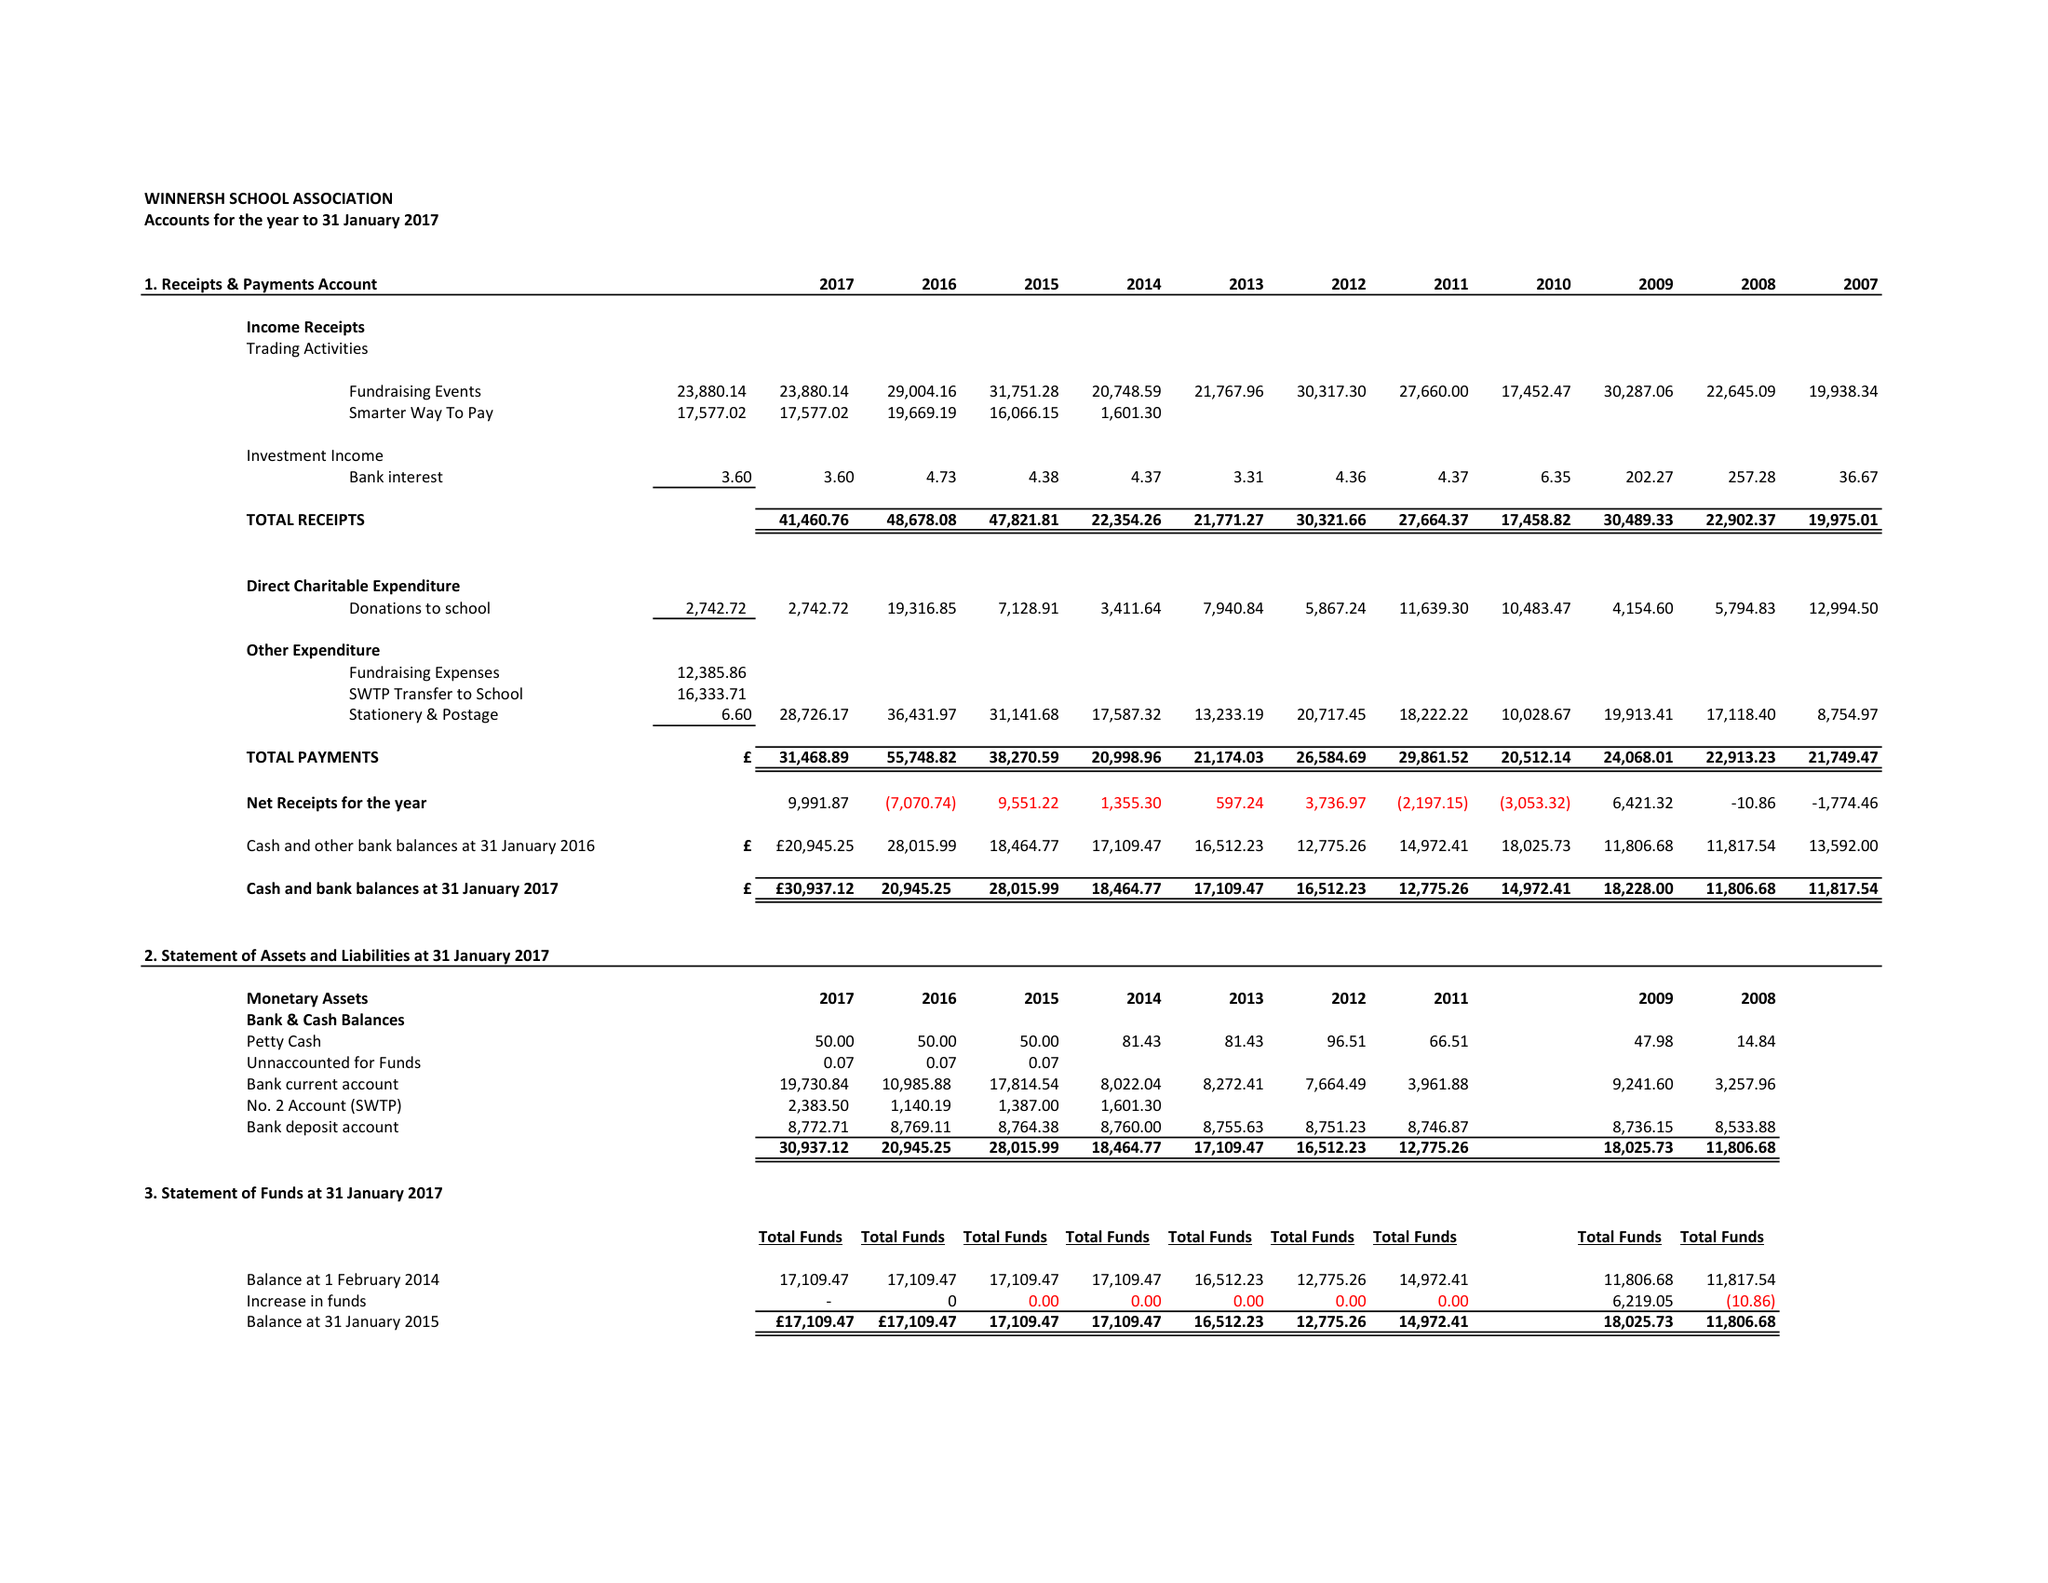What is the value for the charity_name?
Answer the question using a single word or phrase. Winnersh School Association 